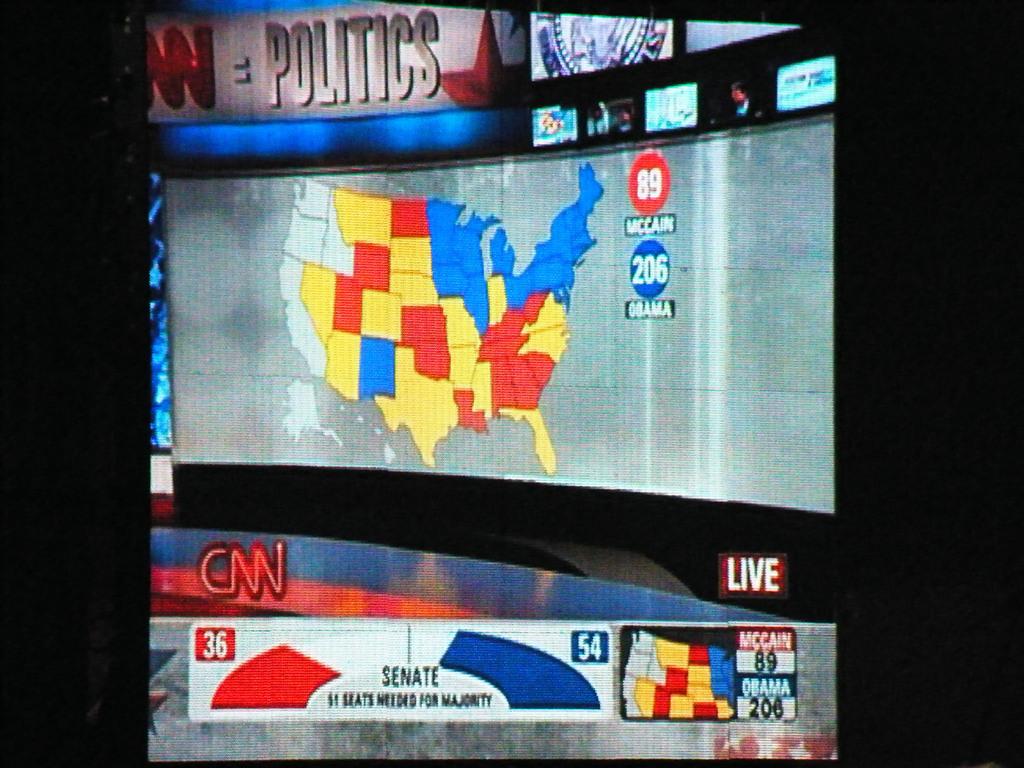What network is this?
Offer a very short reply. Cnn. How many electoral college votes did obama have in this photo?
Your answer should be very brief. 206. 